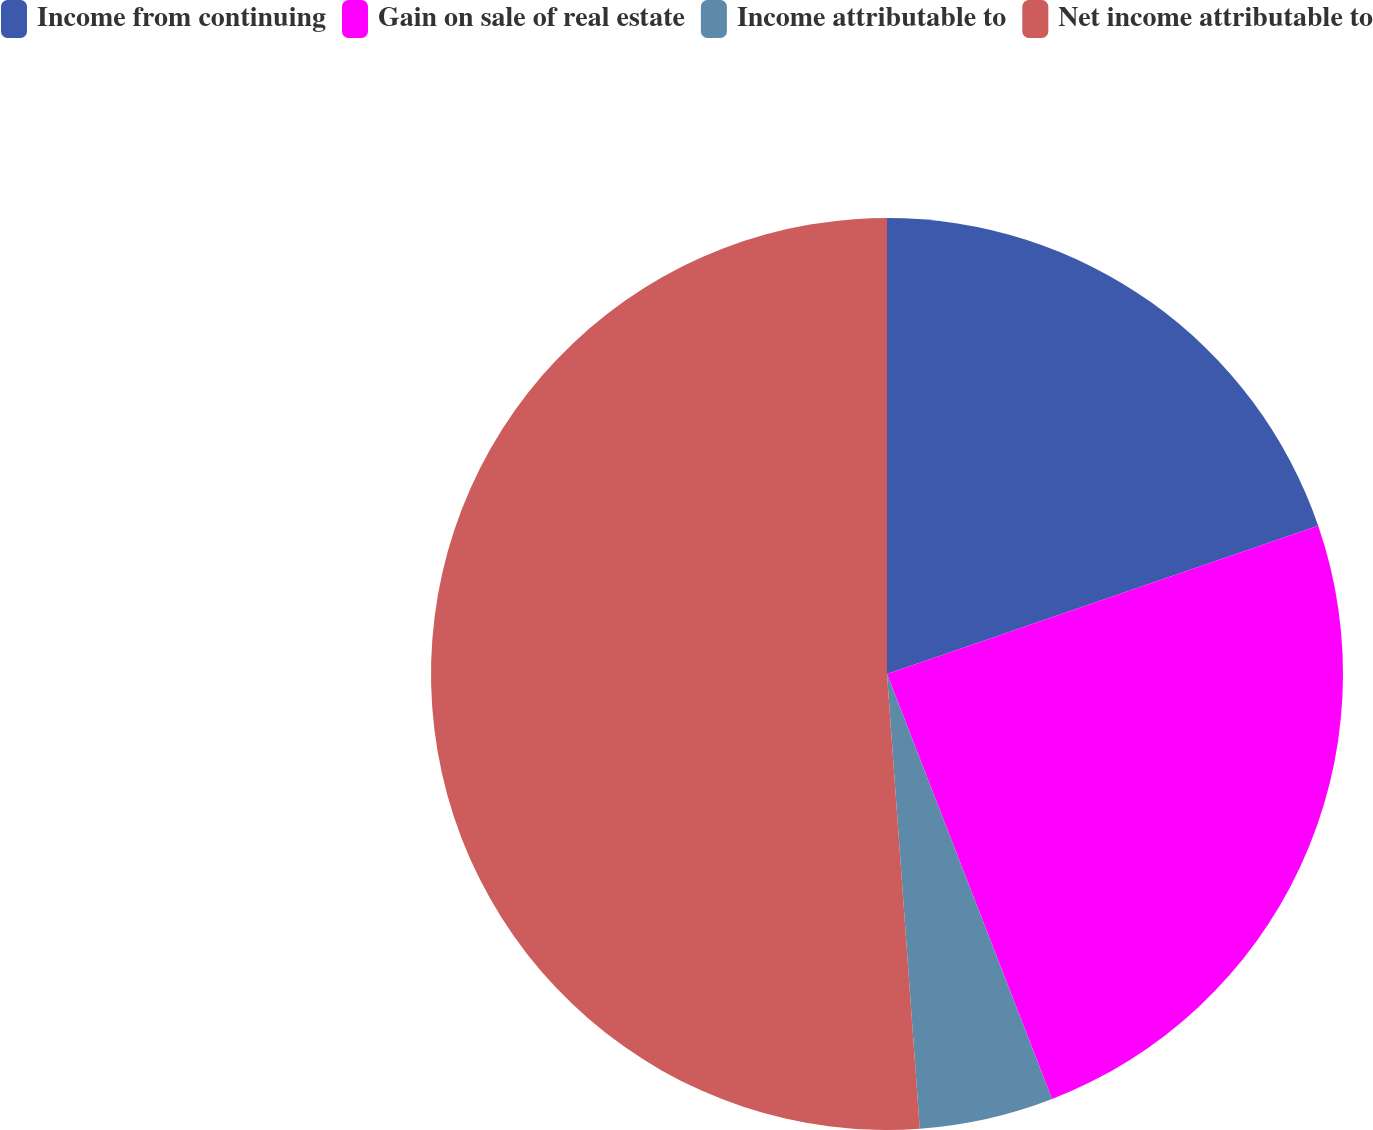Convert chart to OTSL. <chart><loc_0><loc_0><loc_500><loc_500><pie_chart><fcel>Income from continuing<fcel>Gain on sale of real estate<fcel>Income attributable to<fcel>Net income attributable to<nl><fcel>19.73%<fcel>24.38%<fcel>4.75%<fcel>51.15%<nl></chart> 